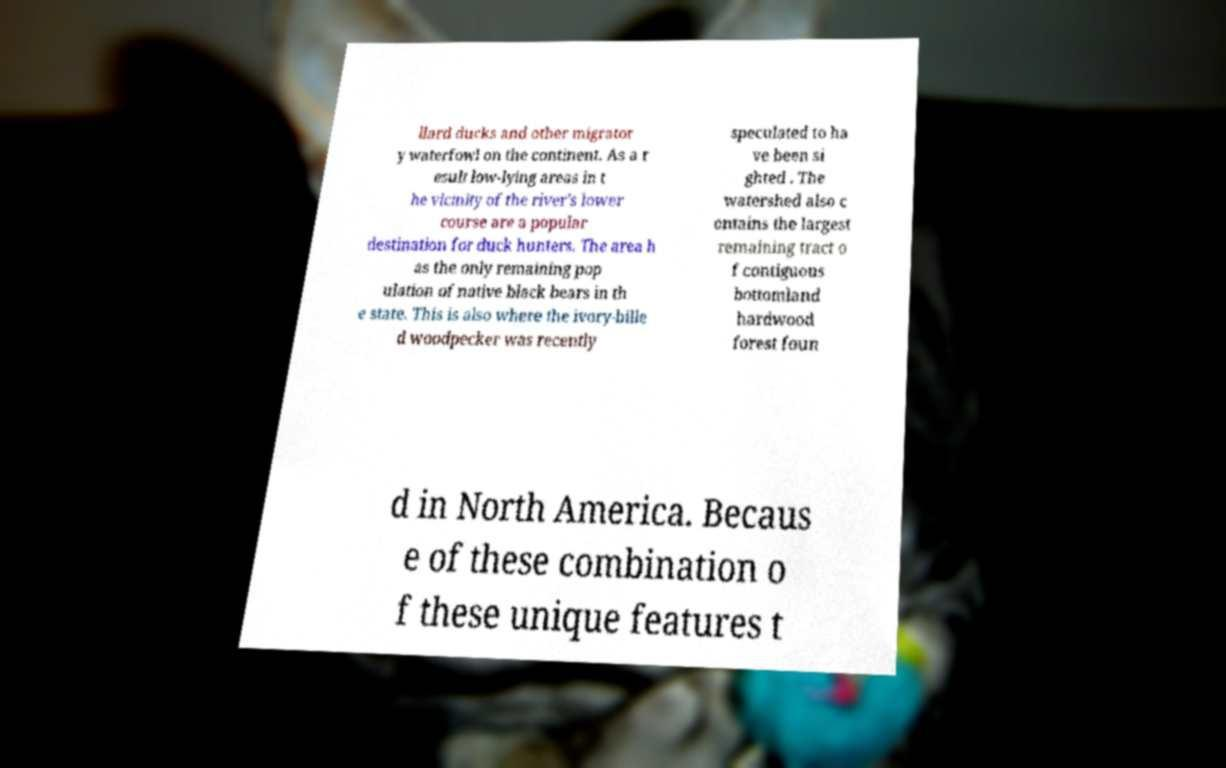I need the written content from this picture converted into text. Can you do that? llard ducks and other migrator y waterfowl on the continent. As a r esult low-lying areas in t he vicinity of the river's lower course are a popular destination for duck hunters. The area h as the only remaining pop ulation of native black bears in th e state. This is also where the ivory-bille d woodpecker was recently speculated to ha ve been si ghted . The watershed also c ontains the largest remaining tract o f contiguous bottomland hardwood forest foun d in North America. Becaus e of these combination o f these unique features t 